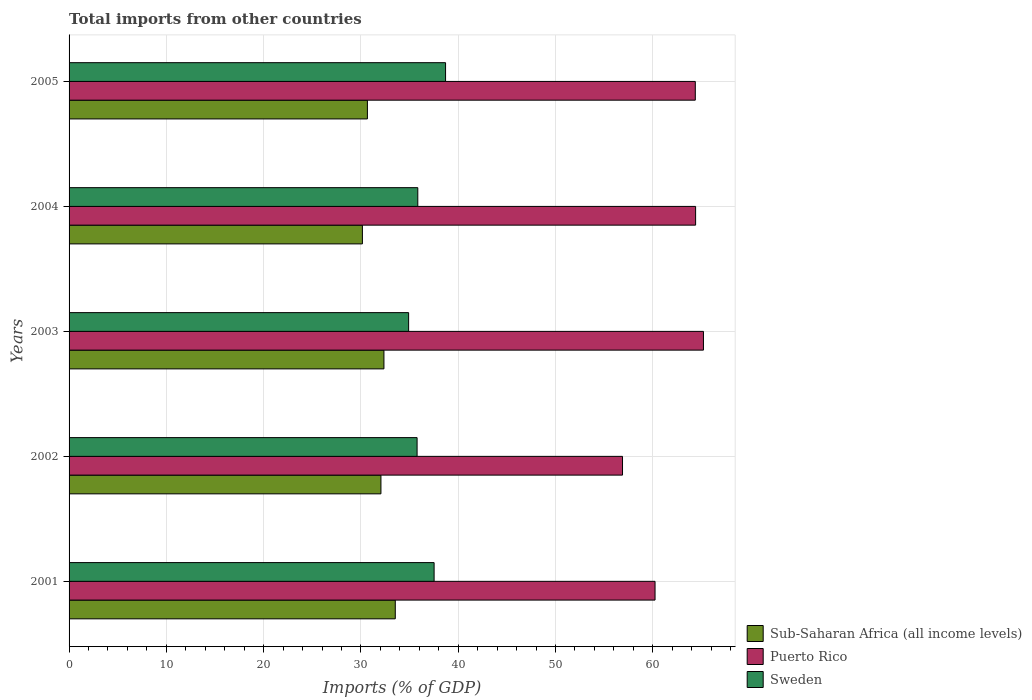How many groups of bars are there?
Your answer should be compact. 5. Are the number of bars on each tick of the Y-axis equal?
Ensure brevity in your answer.  Yes. How many bars are there on the 2nd tick from the bottom?
Ensure brevity in your answer.  3. What is the label of the 3rd group of bars from the top?
Ensure brevity in your answer.  2003. In how many cases, is the number of bars for a given year not equal to the number of legend labels?
Offer a terse response. 0. What is the total imports in Puerto Rico in 2004?
Offer a terse response. 64.4. Across all years, what is the maximum total imports in Puerto Rico?
Provide a succinct answer. 65.21. Across all years, what is the minimum total imports in Puerto Rico?
Ensure brevity in your answer.  56.89. What is the total total imports in Puerto Rico in the graph?
Provide a succinct answer. 311.11. What is the difference between the total imports in Puerto Rico in 2001 and that in 2004?
Provide a short and direct response. -4.17. What is the difference between the total imports in Sweden in 2004 and the total imports in Puerto Rico in 2001?
Make the answer very short. -24.39. What is the average total imports in Sweden per year?
Ensure brevity in your answer.  36.55. In the year 2003, what is the difference between the total imports in Puerto Rico and total imports in Sub-Saharan Africa (all income levels)?
Ensure brevity in your answer.  32.84. What is the ratio of the total imports in Sub-Saharan Africa (all income levels) in 2003 to that in 2004?
Keep it short and to the point. 1.07. Is the difference between the total imports in Puerto Rico in 2003 and 2004 greater than the difference between the total imports in Sub-Saharan Africa (all income levels) in 2003 and 2004?
Provide a succinct answer. No. What is the difference between the highest and the second highest total imports in Sweden?
Offer a terse response. 1.18. What is the difference between the highest and the lowest total imports in Sweden?
Make the answer very short. 3.8. Is it the case that in every year, the sum of the total imports in Puerto Rico and total imports in Sub-Saharan Africa (all income levels) is greater than the total imports in Sweden?
Make the answer very short. Yes. Are all the bars in the graph horizontal?
Offer a very short reply. Yes. Where does the legend appear in the graph?
Your answer should be very brief. Bottom right. What is the title of the graph?
Offer a terse response. Total imports from other countries. What is the label or title of the X-axis?
Ensure brevity in your answer.  Imports (% of GDP). What is the label or title of the Y-axis?
Keep it short and to the point. Years. What is the Imports (% of GDP) in Sub-Saharan Africa (all income levels) in 2001?
Provide a short and direct response. 33.53. What is the Imports (% of GDP) of Puerto Rico in 2001?
Ensure brevity in your answer.  60.23. What is the Imports (% of GDP) in Sweden in 2001?
Keep it short and to the point. 37.52. What is the Imports (% of GDP) in Sub-Saharan Africa (all income levels) in 2002?
Keep it short and to the point. 32.06. What is the Imports (% of GDP) of Puerto Rico in 2002?
Make the answer very short. 56.89. What is the Imports (% of GDP) in Sweden in 2002?
Provide a succinct answer. 35.77. What is the Imports (% of GDP) in Sub-Saharan Africa (all income levels) in 2003?
Provide a short and direct response. 32.37. What is the Imports (% of GDP) of Puerto Rico in 2003?
Give a very brief answer. 65.21. What is the Imports (% of GDP) in Sweden in 2003?
Provide a succinct answer. 34.9. What is the Imports (% of GDP) in Sub-Saharan Africa (all income levels) in 2004?
Provide a succinct answer. 30.15. What is the Imports (% of GDP) of Puerto Rico in 2004?
Give a very brief answer. 64.4. What is the Imports (% of GDP) of Sweden in 2004?
Make the answer very short. 35.85. What is the Imports (% of GDP) of Sub-Saharan Africa (all income levels) in 2005?
Make the answer very short. 30.67. What is the Imports (% of GDP) of Puerto Rico in 2005?
Your response must be concise. 64.37. What is the Imports (% of GDP) in Sweden in 2005?
Offer a terse response. 38.7. Across all years, what is the maximum Imports (% of GDP) of Sub-Saharan Africa (all income levels)?
Provide a short and direct response. 33.53. Across all years, what is the maximum Imports (% of GDP) in Puerto Rico?
Provide a succinct answer. 65.21. Across all years, what is the maximum Imports (% of GDP) in Sweden?
Provide a succinct answer. 38.7. Across all years, what is the minimum Imports (% of GDP) in Sub-Saharan Africa (all income levels)?
Your answer should be very brief. 30.15. Across all years, what is the minimum Imports (% of GDP) in Puerto Rico?
Keep it short and to the point. 56.89. Across all years, what is the minimum Imports (% of GDP) in Sweden?
Provide a short and direct response. 34.9. What is the total Imports (% of GDP) of Sub-Saharan Africa (all income levels) in the graph?
Offer a very short reply. 158.77. What is the total Imports (% of GDP) of Puerto Rico in the graph?
Keep it short and to the point. 311.11. What is the total Imports (% of GDP) in Sweden in the graph?
Keep it short and to the point. 182.75. What is the difference between the Imports (% of GDP) of Sub-Saharan Africa (all income levels) in 2001 and that in 2002?
Keep it short and to the point. 1.48. What is the difference between the Imports (% of GDP) of Puerto Rico in 2001 and that in 2002?
Ensure brevity in your answer.  3.34. What is the difference between the Imports (% of GDP) of Sweden in 2001 and that in 2002?
Offer a very short reply. 1.75. What is the difference between the Imports (% of GDP) in Sub-Saharan Africa (all income levels) in 2001 and that in 2003?
Your response must be concise. 1.17. What is the difference between the Imports (% of GDP) in Puerto Rico in 2001 and that in 2003?
Your response must be concise. -4.98. What is the difference between the Imports (% of GDP) of Sweden in 2001 and that in 2003?
Provide a short and direct response. 2.62. What is the difference between the Imports (% of GDP) of Sub-Saharan Africa (all income levels) in 2001 and that in 2004?
Keep it short and to the point. 3.38. What is the difference between the Imports (% of GDP) of Puerto Rico in 2001 and that in 2004?
Keep it short and to the point. -4.17. What is the difference between the Imports (% of GDP) of Sweden in 2001 and that in 2004?
Offer a terse response. 1.68. What is the difference between the Imports (% of GDP) in Sub-Saharan Africa (all income levels) in 2001 and that in 2005?
Give a very brief answer. 2.87. What is the difference between the Imports (% of GDP) of Puerto Rico in 2001 and that in 2005?
Ensure brevity in your answer.  -4.14. What is the difference between the Imports (% of GDP) in Sweden in 2001 and that in 2005?
Keep it short and to the point. -1.18. What is the difference between the Imports (% of GDP) in Sub-Saharan Africa (all income levels) in 2002 and that in 2003?
Provide a short and direct response. -0.31. What is the difference between the Imports (% of GDP) of Puerto Rico in 2002 and that in 2003?
Your answer should be very brief. -8.32. What is the difference between the Imports (% of GDP) in Sweden in 2002 and that in 2003?
Make the answer very short. 0.87. What is the difference between the Imports (% of GDP) in Sub-Saharan Africa (all income levels) in 2002 and that in 2004?
Provide a short and direct response. 1.9. What is the difference between the Imports (% of GDP) of Puerto Rico in 2002 and that in 2004?
Make the answer very short. -7.51. What is the difference between the Imports (% of GDP) in Sweden in 2002 and that in 2004?
Provide a succinct answer. -0.07. What is the difference between the Imports (% of GDP) of Sub-Saharan Africa (all income levels) in 2002 and that in 2005?
Your answer should be compact. 1.39. What is the difference between the Imports (% of GDP) of Puerto Rico in 2002 and that in 2005?
Offer a terse response. -7.48. What is the difference between the Imports (% of GDP) of Sweden in 2002 and that in 2005?
Your answer should be very brief. -2.93. What is the difference between the Imports (% of GDP) of Sub-Saharan Africa (all income levels) in 2003 and that in 2004?
Your answer should be very brief. 2.21. What is the difference between the Imports (% of GDP) in Puerto Rico in 2003 and that in 2004?
Keep it short and to the point. 0.81. What is the difference between the Imports (% of GDP) of Sweden in 2003 and that in 2004?
Your answer should be very brief. -0.94. What is the difference between the Imports (% of GDP) of Sub-Saharan Africa (all income levels) in 2003 and that in 2005?
Provide a short and direct response. 1.7. What is the difference between the Imports (% of GDP) of Puerto Rico in 2003 and that in 2005?
Give a very brief answer. 0.84. What is the difference between the Imports (% of GDP) of Sweden in 2003 and that in 2005?
Your response must be concise. -3.8. What is the difference between the Imports (% of GDP) of Sub-Saharan Africa (all income levels) in 2004 and that in 2005?
Ensure brevity in your answer.  -0.51. What is the difference between the Imports (% of GDP) in Puerto Rico in 2004 and that in 2005?
Offer a terse response. 0.03. What is the difference between the Imports (% of GDP) of Sweden in 2004 and that in 2005?
Give a very brief answer. -2.85. What is the difference between the Imports (% of GDP) in Sub-Saharan Africa (all income levels) in 2001 and the Imports (% of GDP) in Puerto Rico in 2002?
Provide a short and direct response. -23.36. What is the difference between the Imports (% of GDP) in Sub-Saharan Africa (all income levels) in 2001 and the Imports (% of GDP) in Sweden in 2002?
Your answer should be compact. -2.24. What is the difference between the Imports (% of GDP) of Puerto Rico in 2001 and the Imports (% of GDP) of Sweden in 2002?
Ensure brevity in your answer.  24.46. What is the difference between the Imports (% of GDP) of Sub-Saharan Africa (all income levels) in 2001 and the Imports (% of GDP) of Puerto Rico in 2003?
Offer a terse response. -31.68. What is the difference between the Imports (% of GDP) in Sub-Saharan Africa (all income levels) in 2001 and the Imports (% of GDP) in Sweden in 2003?
Give a very brief answer. -1.37. What is the difference between the Imports (% of GDP) of Puerto Rico in 2001 and the Imports (% of GDP) of Sweden in 2003?
Ensure brevity in your answer.  25.33. What is the difference between the Imports (% of GDP) of Sub-Saharan Africa (all income levels) in 2001 and the Imports (% of GDP) of Puerto Rico in 2004?
Offer a very short reply. -30.87. What is the difference between the Imports (% of GDP) of Sub-Saharan Africa (all income levels) in 2001 and the Imports (% of GDP) of Sweden in 2004?
Your answer should be compact. -2.31. What is the difference between the Imports (% of GDP) of Puerto Rico in 2001 and the Imports (% of GDP) of Sweden in 2004?
Your answer should be compact. 24.39. What is the difference between the Imports (% of GDP) in Sub-Saharan Africa (all income levels) in 2001 and the Imports (% of GDP) in Puerto Rico in 2005?
Offer a very short reply. -30.84. What is the difference between the Imports (% of GDP) in Sub-Saharan Africa (all income levels) in 2001 and the Imports (% of GDP) in Sweden in 2005?
Make the answer very short. -5.17. What is the difference between the Imports (% of GDP) in Puerto Rico in 2001 and the Imports (% of GDP) in Sweden in 2005?
Offer a very short reply. 21.53. What is the difference between the Imports (% of GDP) of Sub-Saharan Africa (all income levels) in 2002 and the Imports (% of GDP) of Puerto Rico in 2003?
Offer a very short reply. -33.15. What is the difference between the Imports (% of GDP) of Sub-Saharan Africa (all income levels) in 2002 and the Imports (% of GDP) of Sweden in 2003?
Provide a short and direct response. -2.85. What is the difference between the Imports (% of GDP) in Puerto Rico in 2002 and the Imports (% of GDP) in Sweden in 2003?
Offer a very short reply. 21.99. What is the difference between the Imports (% of GDP) of Sub-Saharan Africa (all income levels) in 2002 and the Imports (% of GDP) of Puerto Rico in 2004?
Make the answer very short. -32.35. What is the difference between the Imports (% of GDP) of Sub-Saharan Africa (all income levels) in 2002 and the Imports (% of GDP) of Sweden in 2004?
Offer a very short reply. -3.79. What is the difference between the Imports (% of GDP) of Puerto Rico in 2002 and the Imports (% of GDP) of Sweden in 2004?
Provide a succinct answer. 21.04. What is the difference between the Imports (% of GDP) in Sub-Saharan Africa (all income levels) in 2002 and the Imports (% of GDP) in Puerto Rico in 2005?
Provide a short and direct response. -32.31. What is the difference between the Imports (% of GDP) in Sub-Saharan Africa (all income levels) in 2002 and the Imports (% of GDP) in Sweden in 2005?
Offer a terse response. -6.64. What is the difference between the Imports (% of GDP) in Puerto Rico in 2002 and the Imports (% of GDP) in Sweden in 2005?
Provide a short and direct response. 18.19. What is the difference between the Imports (% of GDP) of Sub-Saharan Africa (all income levels) in 2003 and the Imports (% of GDP) of Puerto Rico in 2004?
Keep it short and to the point. -32.04. What is the difference between the Imports (% of GDP) in Sub-Saharan Africa (all income levels) in 2003 and the Imports (% of GDP) in Sweden in 2004?
Make the answer very short. -3.48. What is the difference between the Imports (% of GDP) of Puerto Rico in 2003 and the Imports (% of GDP) of Sweden in 2004?
Make the answer very short. 29.36. What is the difference between the Imports (% of GDP) of Sub-Saharan Africa (all income levels) in 2003 and the Imports (% of GDP) of Puerto Rico in 2005?
Offer a very short reply. -32.01. What is the difference between the Imports (% of GDP) in Sub-Saharan Africa (all income levels) in 2003 and the Imports (% of GDP) in Sweden in 2005?
Your response must be concise. -6.33. What is the difference between the Imports (% of GDP) of Puerto Rico in 2003 and the Imports (% of GDP) of Sweden in 2005?
Keep it short and to the point. 26.51. What is the difference between the Imports (% of GDP) in Sub-Saharan Africa (all income levels) in 2004 and the Imports (% of GDP) in Puerto Rico in 2005?
Give a very brief answer. -34.22. What is the difference between the Imports (% of GDP) in Sub-Saharan Africa (all income levels) in 2004 and the Imports (% of GDP) in Sweden in 2005?
Offer a terse response. -8.55. What is the difference between the Imports (% of GDP) of Puerto Rico in 2004 and the Imports (% of GDP) of Sweden in 2005?
Ensure brevity in your answer.  25.7. What is the average Imports (% of GDP) of Sub-Saharan Africa (all income levels) per year?
Offer a very short reply. 31.75. What is the average Imports (% of GDP) of Puerto Rico per year?
Offer a terse response. 62.22. What is the average Imports (% of GDP) of Sweden per year?
Give a very brief answer. 36.55. In the year 2001, what is the difference between the Imports (% of GDP) of Sub-Saharan Africa (all income levels) and Imports (% of GDP) of Puerto Rico?
Provide a short and direct response. -26.7. In the year 2001, what is the difference between the Imports (% of GDP) of Sub-Saharan Africa (all income levels) and Imports (% of GDP) of Sweden?
Keep it short and to the point. -3.99. In the year 2001, what is the difference between the Imports (% of GDP) in Puerto Rico and Imports (% of GDP) in Sweden?
Ensure brevity in your answer.  22.71. In the year 2002, what is the difference between the Imports (% of GDP) of Sub-Saharan Africa (all income levels) and Imports (% of GDP) of Puerto Rico?
Your answer should be very brief. -24.83. In the year 2002, what is the difference between the Imports (% of GDP) in Sub-Saharan Africa (all income levels) and Imports (% of GDP) in Sweden?
Your answer should be compact. -3.72. In the year 2002, what is the difference between the Imports (% of GDP) of Puerto Rico and Imports (% of GDP) of Sweden?
Offer a terse response. 21.12. In the year 2003, what is the difference between the Imports (% of GDP) of Sub-Saharan Africa (all income levels) and Imports (% of GDP) of Puerto Rico?
Ensure brevity in your answer.  -32.84. In the year 2003, what is the difference between the Imports (% of GDP) of Sub-Saharan Africa (all income levels) and Imports (% of GDP) of Sweden?
Keep it short and to the point. -2.54. In the year 2003, what is the difference between the Imports (% of GDP) of Puerto Rico and Imports (% of GDP) of Sweden?
Ensure brevity in your answer.  30.31. In the year 2004, what is the difference between the Imports (% of GDP) of Sub-Saharan Africa (all income levels) and Imports (% of GDP) of Puerto Rico?
Your response must be concise. -34.25. In the year 2004, what is the difference between the Imports (% of GDP) in Sub-Saharan Africa (all income levels) and Imports (% of GDP) in Sweden?
Provide a succinct answer. -5.69. In the year 2004, what is the difference between the Imports (% of GDP) in Puerto Rico and Imports (% of GDP) in Sweden?
Offer a terse response. 28.56. In the year 2005, what is the difference between the Imports (% of GDP) in Sub-Saharan Africa (all income levels) and Imports (% of GDP) in Puerto Rico?
Provide a succinct answer. -33.71. In the year 2005, what is the difference between the Imports (% of GDP) in Sub-Saharan Africa (all income levels) and Imports (% of GDP) in Sweden?
Offer a very short reply. -8.03. In the year 2005, what is the difference between the Imports (% of GDP) in Puerto Rico and Imports (% of GDP) in Sweden?
Make the answer very short. 25.67. What is the ratio of the Imports (% of GDP) in Sub-Saharan Africa (all income levels) in 2001 to that in 2002?
Your answer should be compact. 1.05. What is the ratio of the Imports (% of GDP) of Puerto Rico in 2001 to that in 2002?
Provide a succinct answer. 1.06. What is the ratio of the Imports (% of GDP) of Sweden in 2001 to that in 2002?
Make the answer very short. 1.05. What is the ratio of the Imports (% of GDP) in Sub-Saharan Africa (all income levels) in 2001 to that in 2003?
Make the answer very short. 1.04. What is the ratio of the Imports (% of GDP) in Puerto Rico in 2001 to that in 2003?
Keep it short and to the point. 0.92. What is the ratio of the Imports (% of GDP) of Sweden in 2001 to that in 2003?
Your answer should be compact. 1.07. What is the ratio of the Imports (% of GDP) in Sub-Saharan Africa (all income levels) in 2001 to that in 2004?
Provide a succinct answer. 1.11. What is the ratio of the Imports (% of GDP) of Puerto Rico in 2001 to that in 2004?
Ensure brevity in your answer.  0.94. What is the ratio of the Imports (% of GDP) of Sweden in 2001 to that in 2004?
Offer a terse response. 1.05. What is the ratio of the Imports (% of GDP) in Sub-Saharan Africa (all income levels) in 2001 to that in 2005?
Your answer should be compact. 1.09. What is the ratio of the Imports (% of GDP) of Puerto Rico in 2001 to that in 2005?
Provide a succinct answer. 0.94. What is the ratio of the Imports (% of GDP) of Sweden in 2001 to that in 2005?
Your answer should be very brief. 0.97. What is the ratio of the Imports (% of GDP) of Sub-Saharan Africa (all income levels) in 2002 to that in 2003?
Keep it short and to the point. 0.99. What is the ratio of the Imports (% of GDP) in Puerto Rico in 2002 to that in 2003?
Offer a very short reply. 0.87. What is the ratio of the Imports (% of GDP) in Sweden in 2002 to that in 2003?
Provide a short and direct response. 1.02. What is the ratio of the Imports (% of GDP) of Sub-Saharan Africa (all income levels) in 2002 to that in 2004?
Provide a short and direct response. 1.06. What is the ratio of the Imports (% of GDP) of Puerto Rico in 2002 to that in 2004?
Make the answer very short. 0.88. What is the ratio of the Imports (% of GDP) of Sweden in 2002 to that in 2004?
Provide a short and direct response. 1. What is the ratio of the Imports (% of GDP) in Sub-Saharan Africa (all income levels) in 2002 to that in 2005?
Offer a very short reply. 1.05. What is the ratio of the Imports (% of GDP) in Puerto Rico in 2002 to that in 2005?
Keep it short and to the point. 0.88. What is the ratio of the Imports (% of GDP) of Sweden in 2002 to that in 2005?
Offer a very short reply. 0.92. What is the ratio of the Imports (% of GDP) of Sub-Saharan Africa (all income levels) in 2003 to that in 2004?
Your answer should be compact. 1.07. What is the ratio of the Imports (% of GDP) of Puerto Rico in 2003 to that in 2004?
Make the answer very short. 1.01. What is the ratio of the Imports (% of GDP) of Sweden in 2003 to that in 2004?
Your answer should be very brief. 0.97. What is the ratio of the Imports (% of GDP) in Sub-Saharan Africa (all income levels) in 2003 to that in 2005?
Offer a terse response. 1.06. What is the ratio of the Imports (% of GDP) of Sweden in 2003 to that in 2005?
Give a very brief answer. 0.9. What is the ratio of the Imports (% of GDP) of Sub-Saharan Africa (all income levels) in 2004 to that in 2005?
Keep it short and to the point. 0.98. What is the ratio of the Imports (% of GDP) of Sweden in 2004 to that in 2005?
Give a very brief answer. 0.93. What is the difference between the highest and the second highest Imports (% of GDP) in Sub-Saharan Africa (all income levels)?
Offer a very short reply. 1.17. What is the difference between the highest and the second highest Imports (% of GDP) of Puerto Rico?
Offer a terse response. 0.81. What is the difference between the highest and the second highest Imports (% of GDP) in Sweden?
Your answer should be compact. 1.18. What is the difference between the highest and the lowest Imports (% of GDP) of Sub-Saharan Africa (all income levels)?
Make the answer very short. 3.38. What is the difference between the highest and the lowest Imports (% of GDP) of Puerto Rico?
Your answer should be very brief. 8.32. What is the difference between the highest and the lowest Imports (% of GDP) of Sweden?
Make the answer very short. 3.8. 